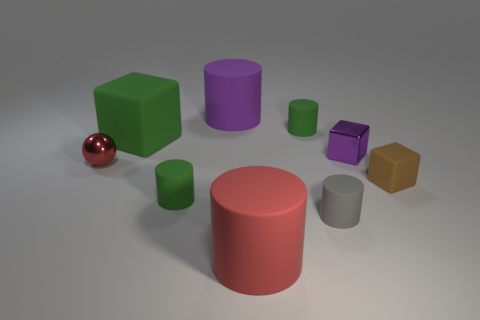Subtract all purple rubber cylinders. How many cylinders are left? 4 Subtract all green cylinders. How many were subtracted if there are1green cylinders left? 1 Subtract 1 balls. How many balls are left? 0 Subtract all cyan cylinders. Subtract all purple blocks. How many cylinders are left? 5 Subtract all blue spheres. How many purple blocks are left? 1 Subtract all small gray rubber cylinders. Subtract all tiny metal balls. How many objects are left? 7 Add 3 tiny green matte objects. How many tiny green matte objects are left? 5 Add 2 gray cylinders. How many gray cylinders exist? 3 Add 1 big red metallic objects. How many objects exist? 10 Subtract all purple cylinders. How many cylinders are left? 4 